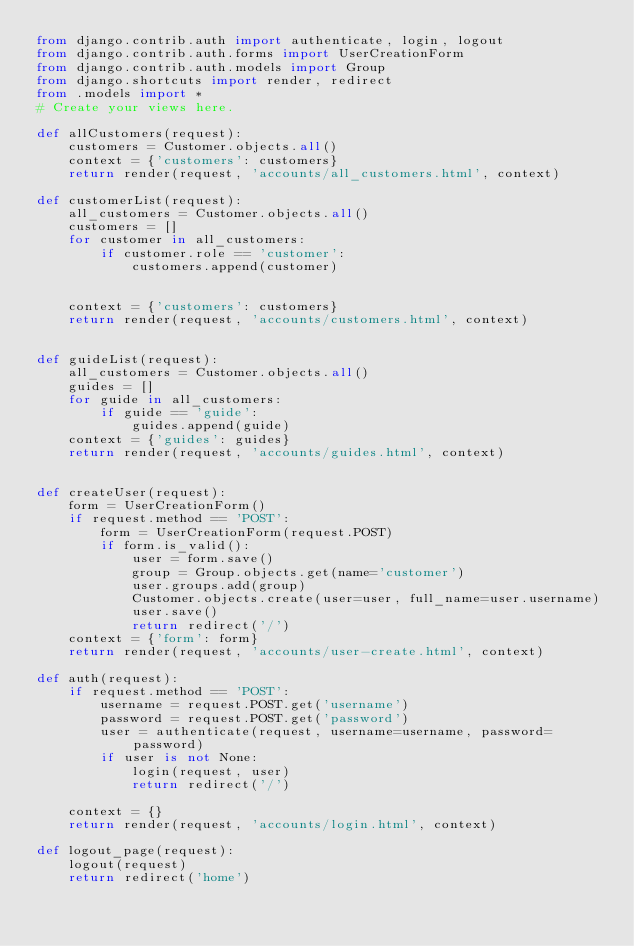<code> <loc_0><loc_0><loc_500><loc_500><_Python_>from django.contrib.auth import authenticate, login, logout
from django.contrib.auth.forms import UserCreationForm
from django.contrib.auth.models import Group
from django.shortcuts import render, redirect
from .models import *
# Create your views here.

def allCustomers(request):
    customers = Customer.objects.all()
    context = {'customers': customers}
    return render(request, 'accounts/all_customers.html', context)

def customerList(request):
    all_customers = Customer.objects.all()
    customers = []
    for customer in all_customers:
        if customer.role == 'customer':
            customers.append(customer)


    context = {'customers': customers}
    return render(request, 'accounts/customers.html', context)


def guideList(request):
    all_customers = Customer.objects.all()
    guides = []
    for guide in all_customers:
        if guide == 'guide':
            guides.append(guide)
    context = {'guides': guides}
    return render(request, 'accounts/guides.html', context)


def createUser(request):
    form = UserCreationForm()
    if request.method == 'POST':
        form = UserCreationForm(request.POST)
        if form.is_valid():
            user = form.save()
            group = Group.objects.get(name='customer')
            user.groups.add(group)
            Customer.objects.create(user=user, full_name=user.username)
            user.save()
            return redirect('/')
    context = {'form': form}
    return render(request, 'accounts/user-create.html', context)

def auth(request):
    if request.method == 'POST':
        username = request.POST.get('username')
        password = request.POST.get('password')
        user = authenticate(request, username=username, password=password)
        if user is not None:
            login(request, user)
            return redirect('/')

    context = {}
    return render(request, 'accounts/login.html', context)

def logout_page(request):
    logout(request)
    return redirect('home')
</code> 